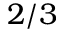<formula> <loc_0><loc_0><loc_500><loc_500>2 / 3</formula> 